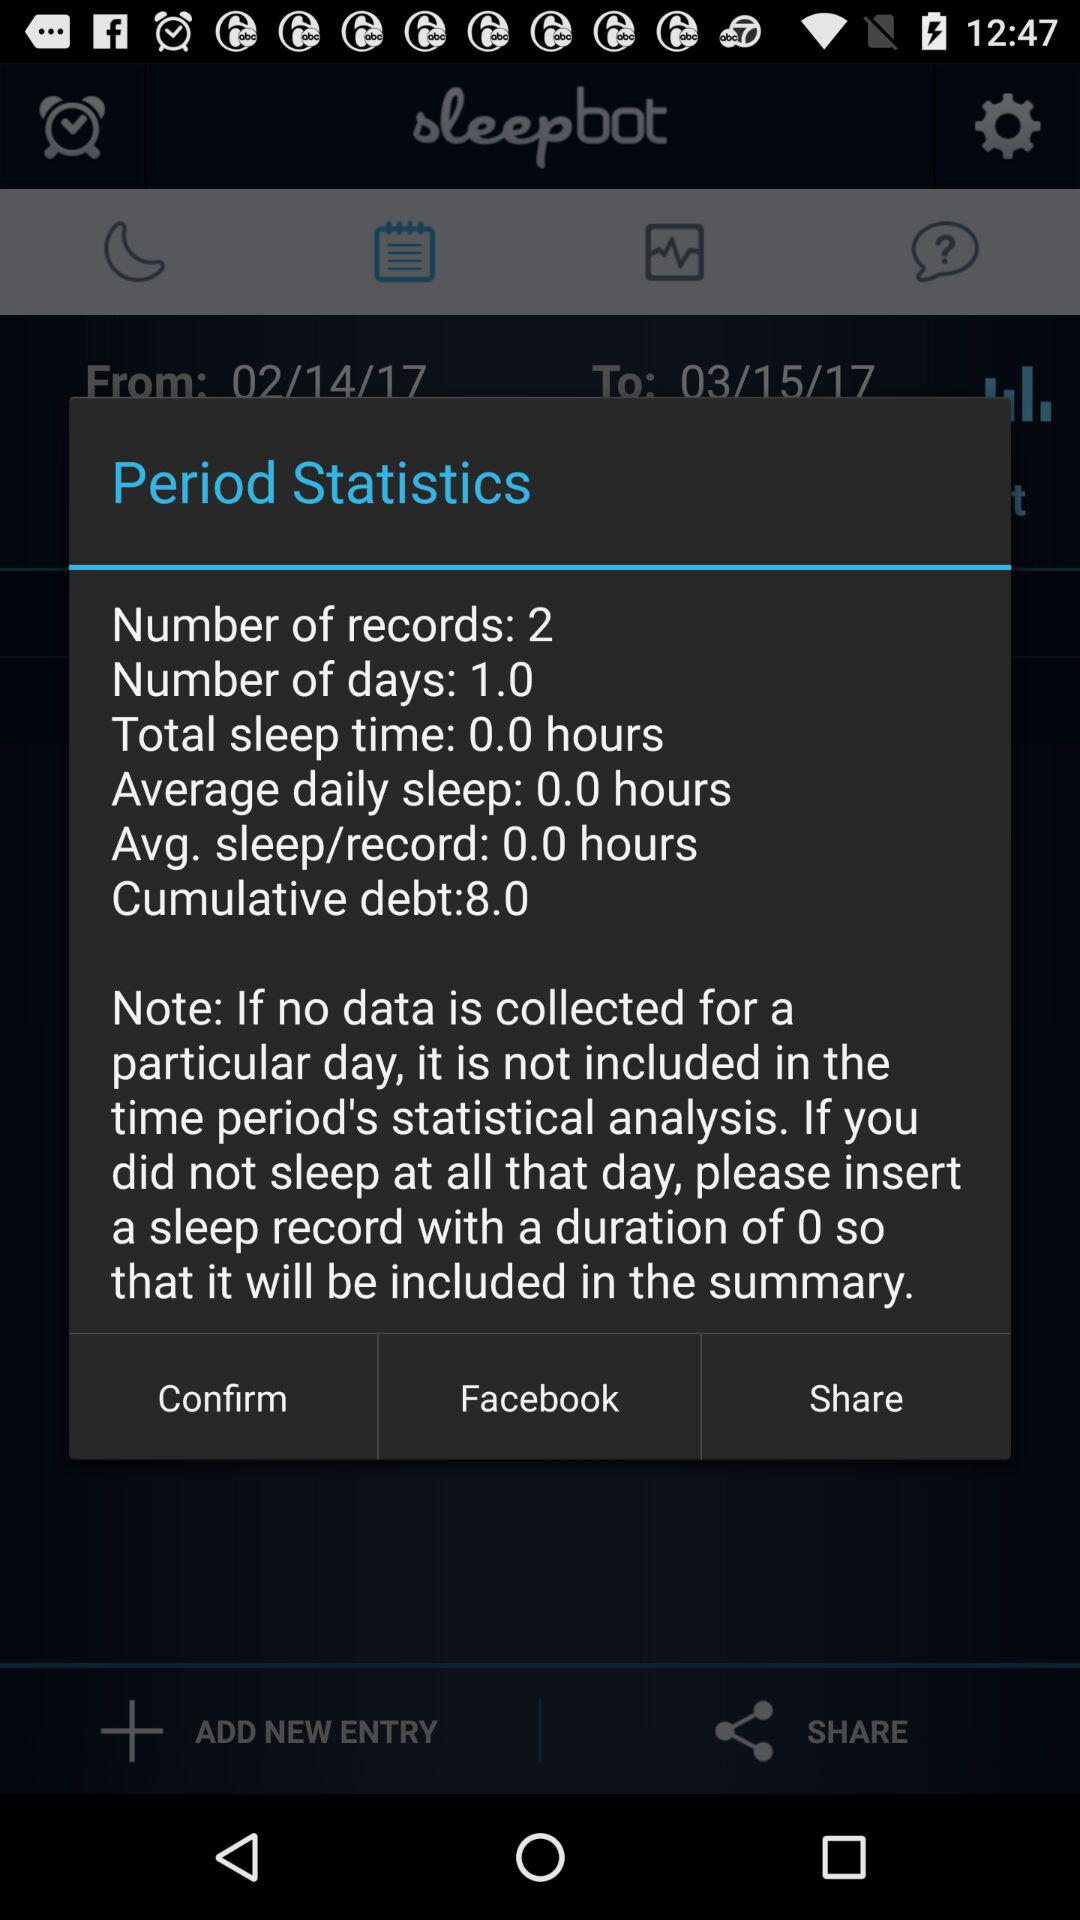How many cumulative debts are there? There is 8.0 cumulative debt. 